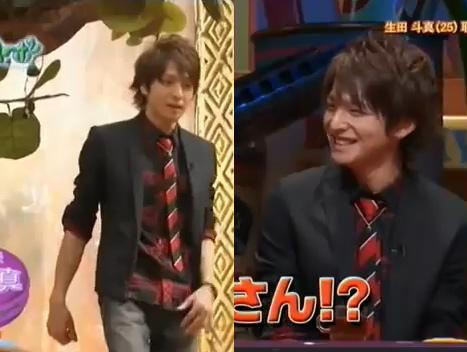Where would the contents of this image probably be seen exactly assis? asia 